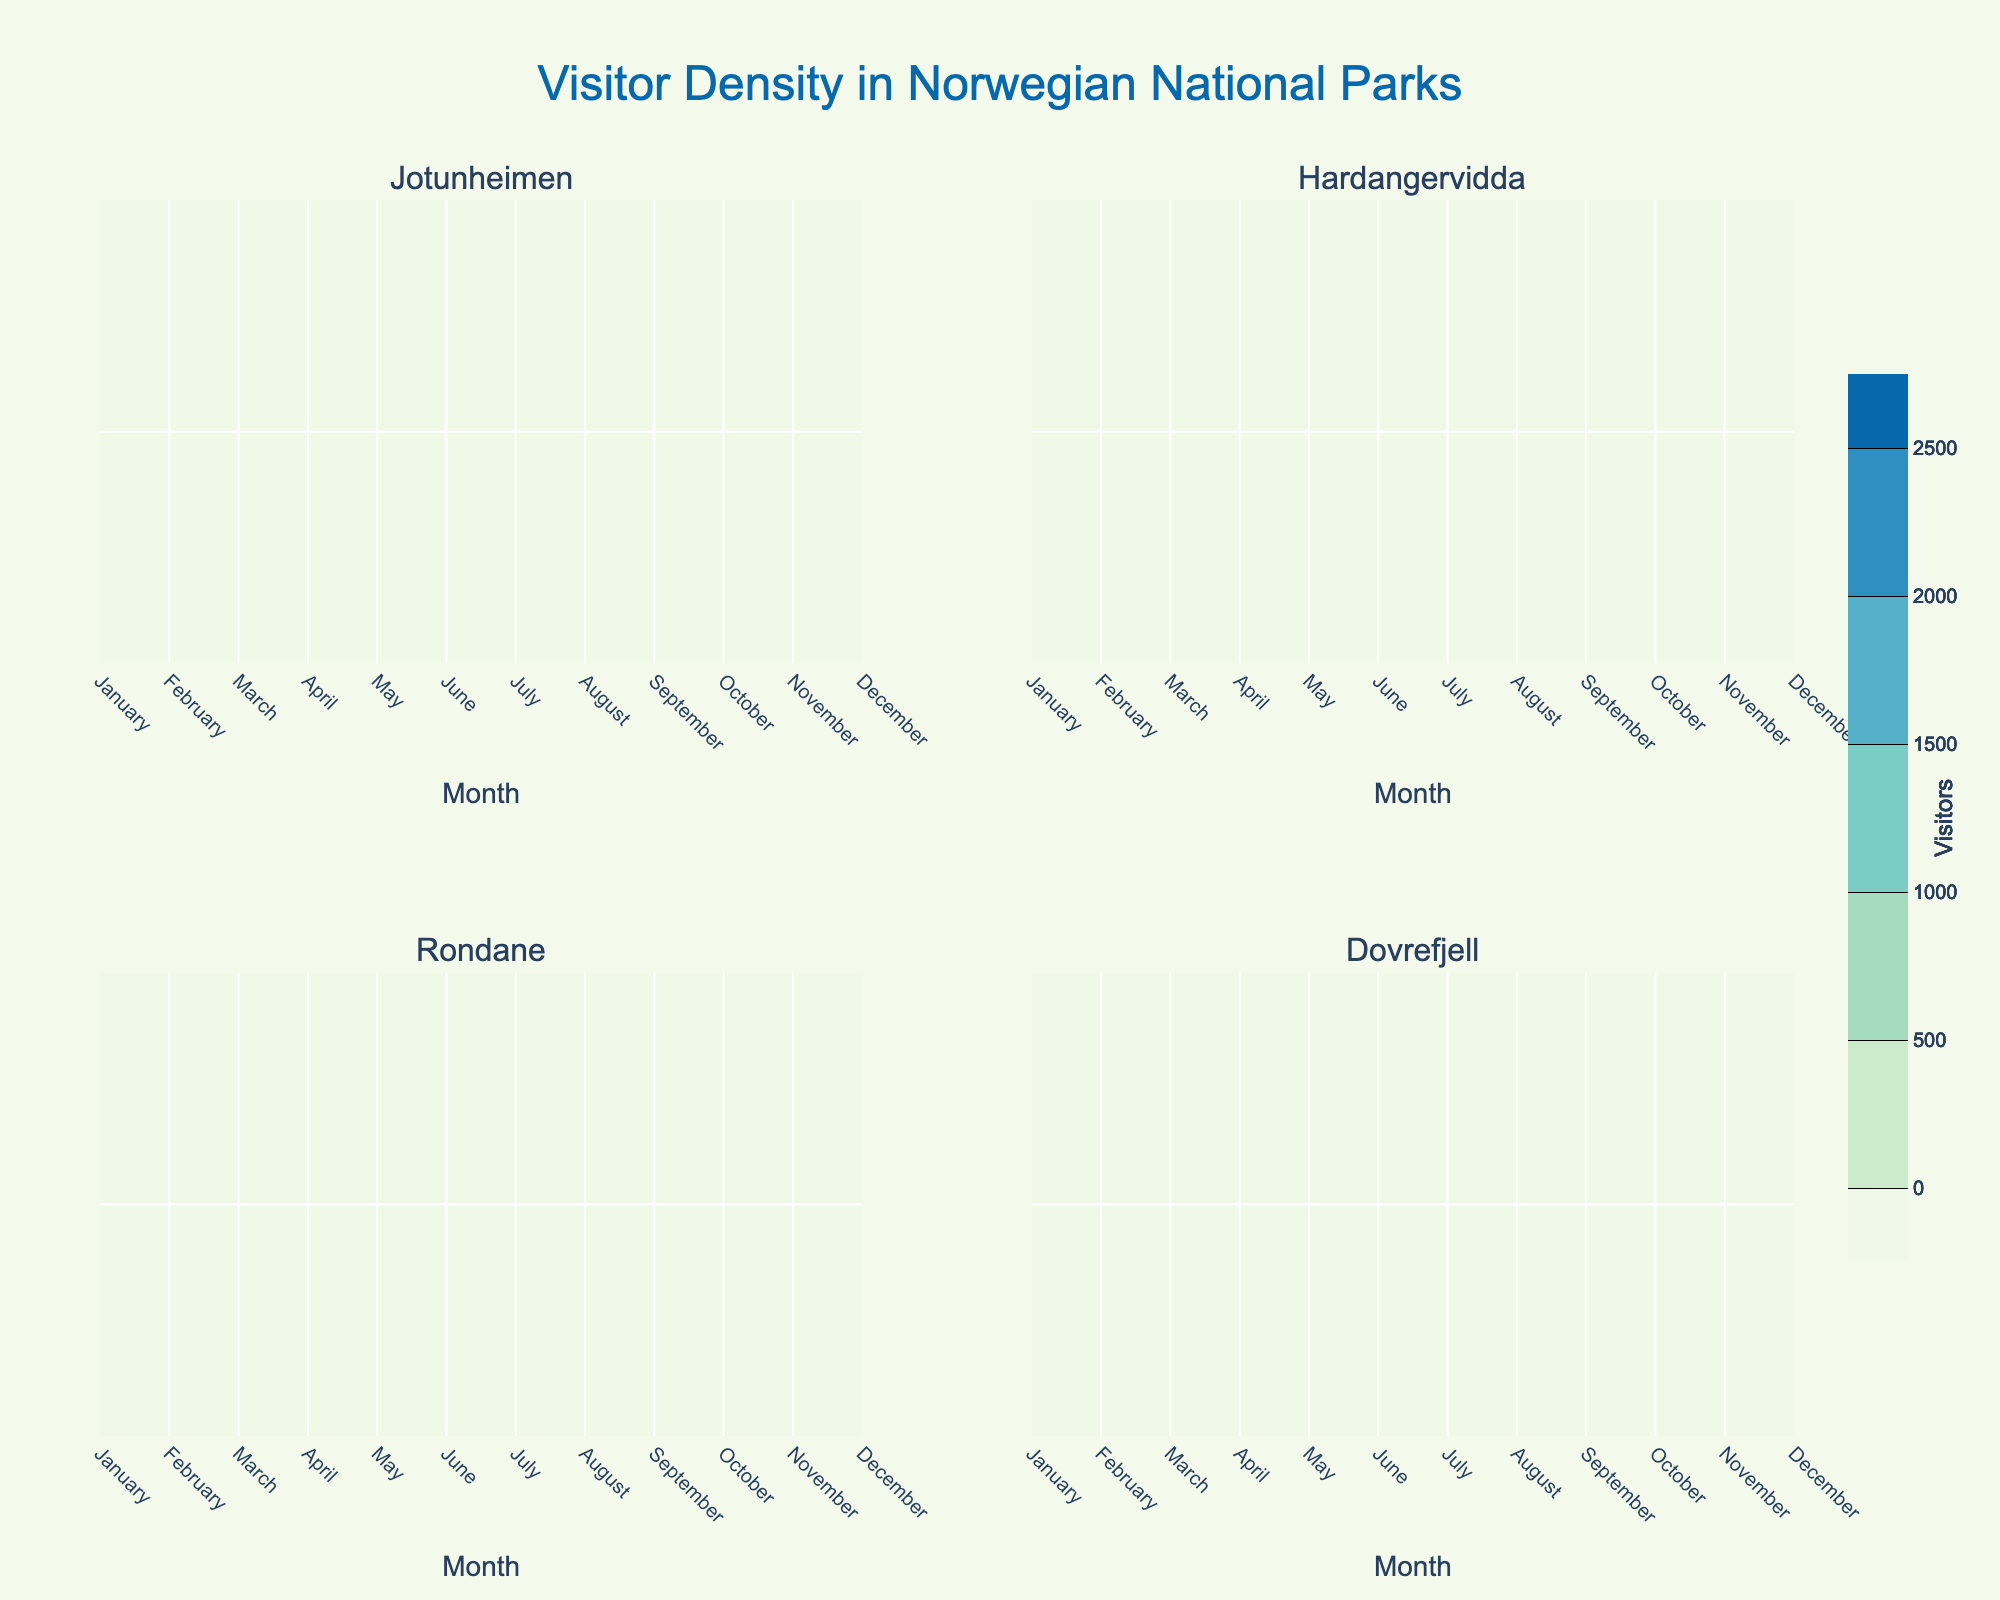Which month has the highest visitor density in Jotunheimen National Park? By looking at the contour graph for Jotunheimen, the highest visitor count peaks in July.
Answer: July Which national park has the highest visitor density in July? By comparing the contour graphs for all parks in July, Jotunheimen has the highest visitor count.
Answer: Jotunheimen Is there a general trend in visitor density across all national parks from January to December? The visitor density in all parks tends to increase from January, peak around July or August, and then decrease towards December.
Answer: Peaks in summer How does the visitor density in April in Dovrefjell compare to Rondane? By observing the contour graphs, the visitor density in April is higher in Dovrefjell than in Rondane.
Answer: Higher in Dovrefjell Which month shows the lowest visitor density across all national parks? January shows the lowest visitor density across all the parks when comparing the contours.
Answer: January In which month is the visitor density roughly the same in all four parks? By observing the visitor density contours, December shows a relatively similar visitor count in all parks.
Answer: December Are there any months where visitor density in Hardangervidda is significantly higher than in other parks? In July, Hardangervidda shows a significantly high visitor density, rivaling that of Jotunheimen.
Answer: July What is the visitor density range for Rondane in October? By examining the contours for Rondane in October, the visitor count is around 1000.
Answer: Around 1000 